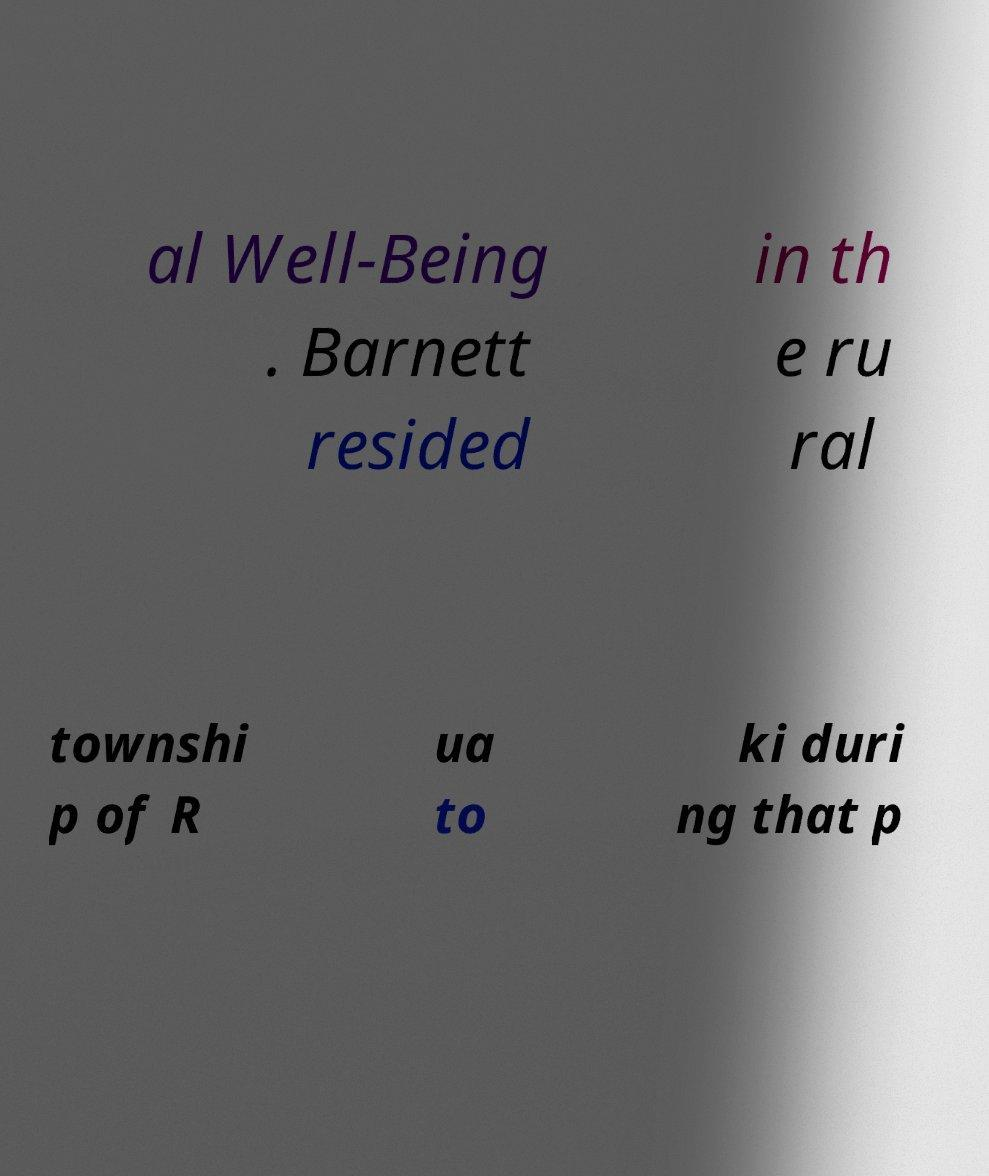Please read and relay the text visible in this image. What does it say? al Well-Being . Barnett resided in th e ru ral townshi p of R ua to ki duri ng that p 